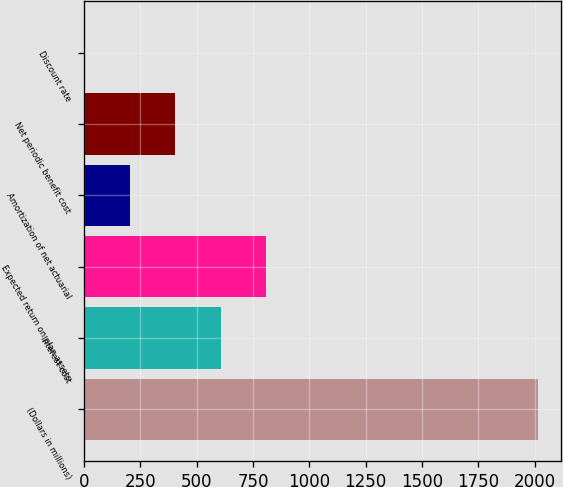Convert chart. <chart><loc_0><loc_0><loc_500><loc_500><bar_chart><fcel>(Dollars in millions)<fcel>Interest cost<fcel>Expected return on plan assets<fcel>Amortization of net actuarial<fcel>Net periodic benefit cost<fcel>Discount rate<nl><fcel>2017<fcel>606.88<fcel>808.32<fcel>204<fcel>405.44<fcel>2.56<nl></chart> 